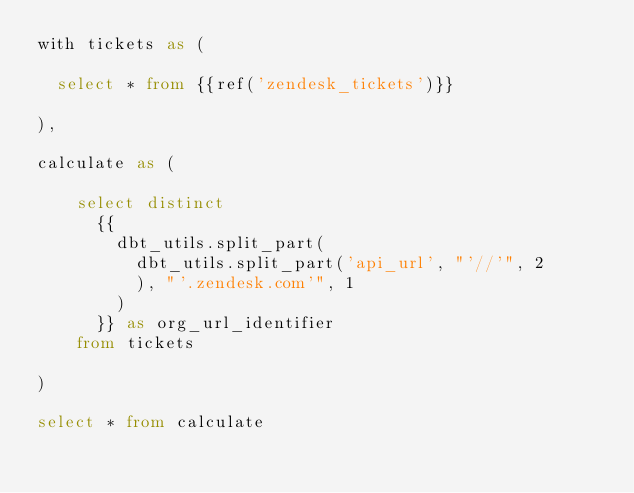<code> <loc_0><loc_0><loc_500><loc_500><_SQL_>with tickets as (

  select * from {{ref('zendesk_tickets')}}

),

calculate as (

    select distinct
      {{ 
        dbt_utils.split_part(
          dbt_utils.split_part('api_url', "'//'", 2
          ), "'.zendesk.com'", 1
        ) 
      }} as org_url_identifier
    from tickets
    
)

select * from calculate
</code> 